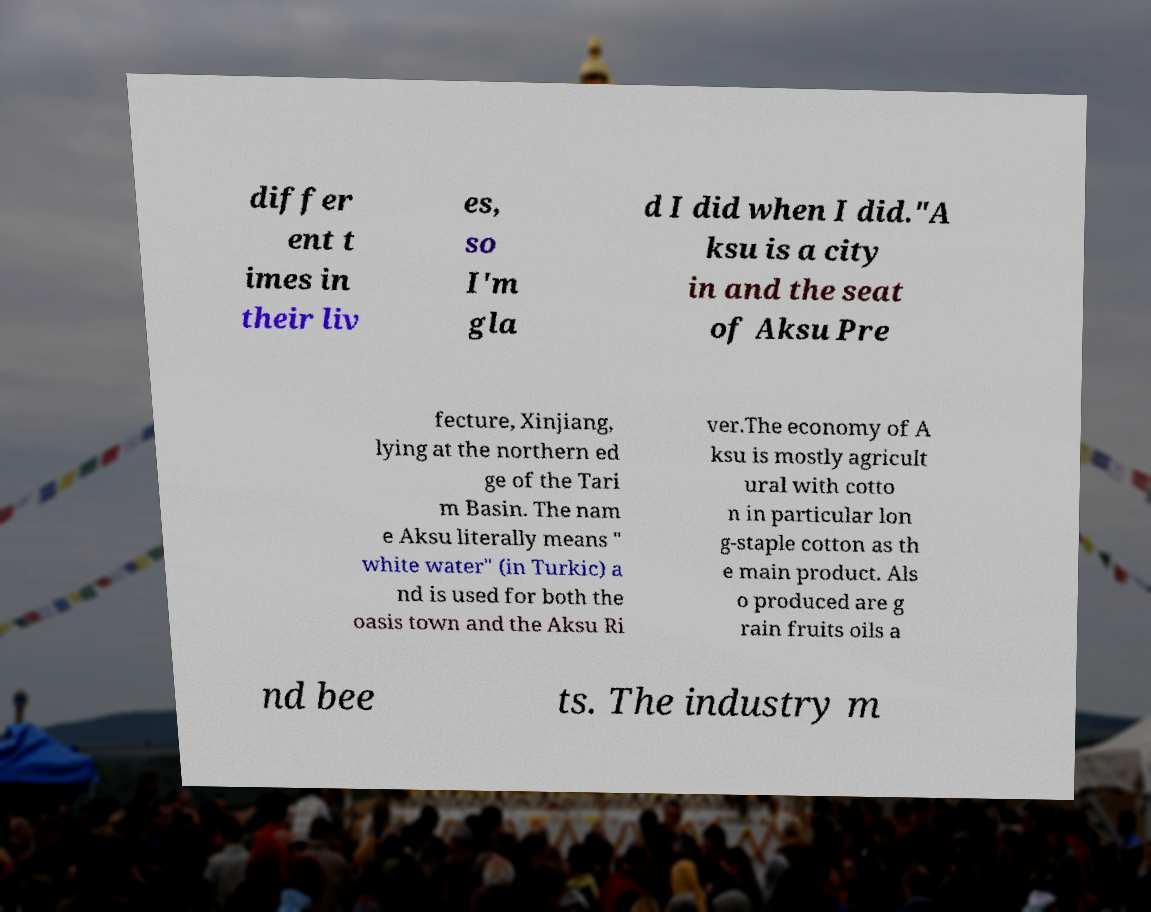Could you extract and type out the text from this image? differ ent t imes in their liv es, so I'm gla d I did when I did."A ksu is a city in and the seat of Aksu Pre fecture, Xinjiang, lying at the northern ed ge of the Tari m Basin. The nam e Aksu literally means " white water" (in Turkic) a nd is used for both the oasis town and the Aksu Ri ver.The economy of A ksu is mostly agricult ural with cotto n in particular lon g-staple cotton as th e main product. Als o produced are g rain fruits oils a nd bee ts. The industry m 